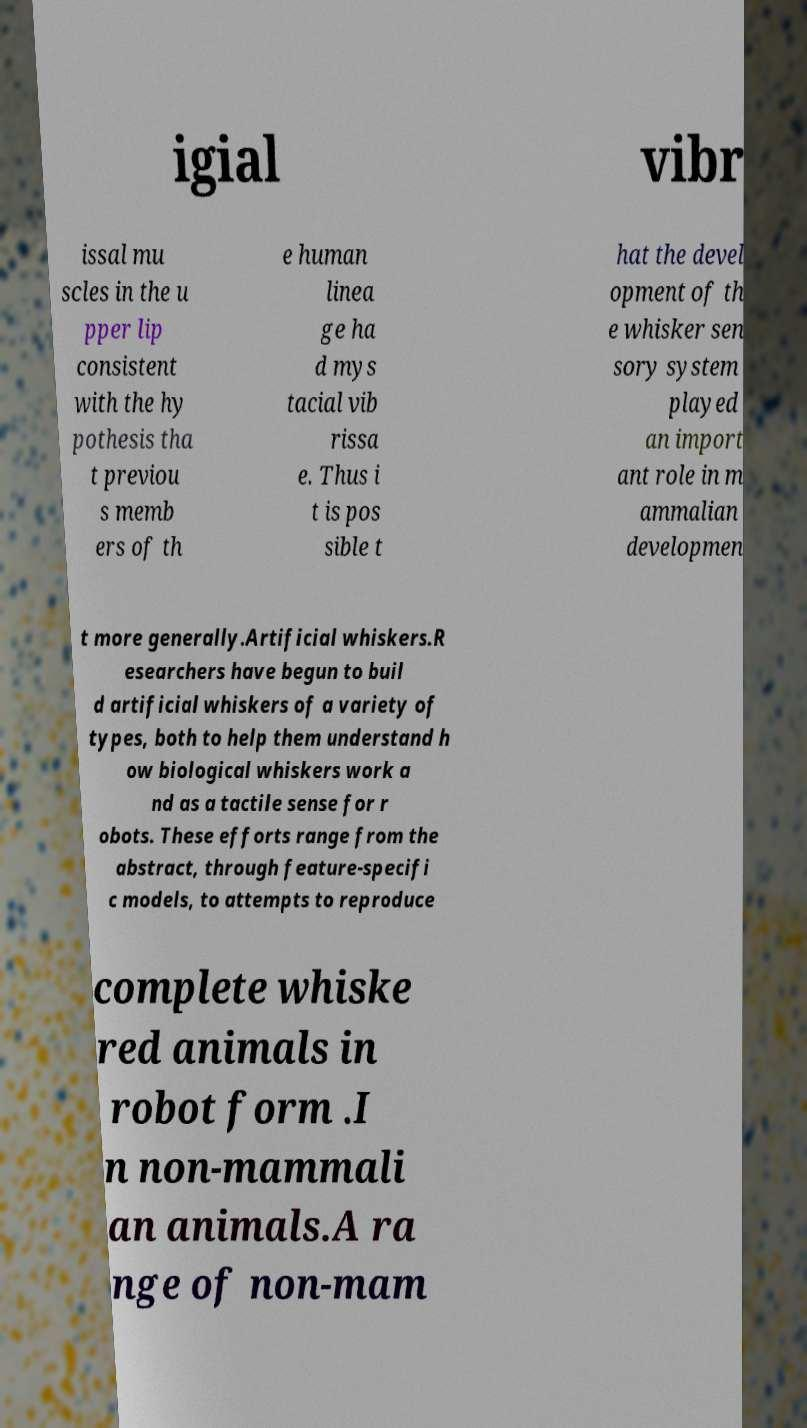Could you extract and type out the text from this image? igial vibr issal mu scles in the u pper lip consistent with the hy pothesis tha t previou s memb ers of th e human linea ge ha d mys tacial vib rissa e. Thus i t is pos sible t hat the devel opment of th e whisker sen sory system played an import ant role in m ammalian developmen t more generally.Artificial whiskers.R esearchers have begun to buil d artificial whiskers of a variety of types, both to help them understand h ow biological whiskers work a nd as a tactile sense for r obots. These efforts range from the abstract, through feature-specifi c models, to attempts to reproduce complete whiske red animals in robot form .I n non-mammali an animals.A ra nge of non-mam 